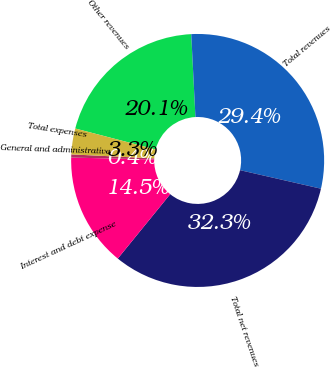Convert chart to OTSL. <chart><loc_0><loc_0><loc_500><loc_500><pie_chart><fcel>Other revenues<fcel>Total revenues<fcel>Total net revenues<fcel>Interest and debt expense<fcel>General and administrative<fcel>Total expenses<nl><fcel>20.13%<fcel>29.39%<fcel>32.29%<fcel>14.49%<fcel>0.4%<fcel>3.3%<nl></chart> 